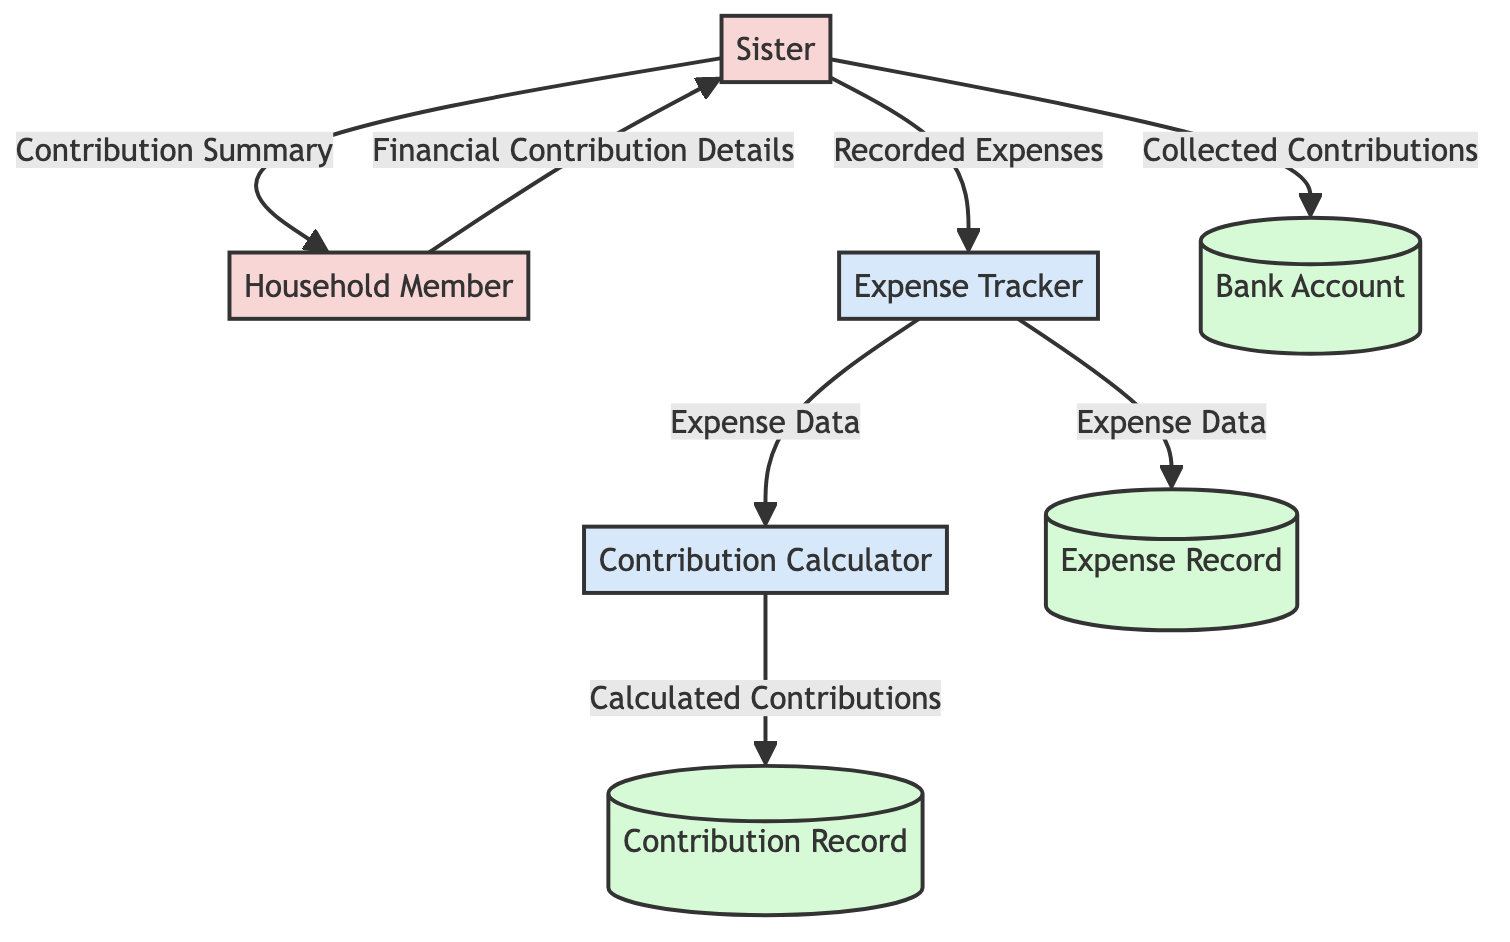What is the first external entity in the diagram? The first external entity listed in the diagram is "Sister." It is identified at the top of the diagram as an external entity that manages the household and provides emotional support.
Answer: Sister How many processes are represented in the diagram? The diagram contains two processes: "Expense Tracker" and "Contribution Calculator." These processes are responsible for managing household expenses and calculating contributions.
Answer: 2 What type of data flows from the Sister to the Bank Account? The data flowing from the Sister to the Bank Account is labeled as "Collected Contributions." This represents the actions of depositing the collected contributions into a centralized bank account.
Answer: Collected Contributions What repository keeps details of household expenses? The repository that keeps details of household expenses is called "Expense Record." It is designated as a data store in the diagram, indicating where expense data is stored.
Answer: Expense Record Which entity receives a summary of contributions from the Sister? The entity that receives a summary of contributions from the Sister is "Household Member." The Sister provides this summary to keep household members informed about their contributions.
Answer: Household Member What type of data is used to determine individual contributions? The type of data used to determine individual contributions is "Expense Data." This data is provided by the Expense Tracker to the Contribution Calculator to calculate contributions.
Answer: Expense Data Which process stores calculated contributions? The process that stores calculated contributions is "Contribution Calculator." The calculated contributions are recorded in the "Contribution Record" data store after being processed.
Answer: Contribution Record How many external entities are depicted in the diagram? There are two external entities depicted in the diagram: "Sister" and "Household Member." These represent the individuals involved in managing financial contributions and expenses.
Answer: 2 What is the relationship between the Expense Tracker and the Contribution Calculator? The relationship between the Expense Tracker and the Contribution Calculator is that the Expense Tracker sends "Expense Data" to the Contribution Calculator to assist in calculating contributions.
Answer: Expense Data 